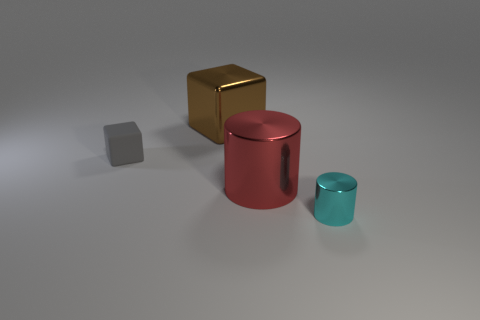Is the number of large metal things that are behind the gray object greater than the number of small brown metallic cylinders?
Offer a very short reply. Yes. Is the number of rubber objects that are on the right side of the rubber block the same as the number of tiny cyan shiny cylinders behind the large block?
Your answer should be very brief. Yes. There is a object that is both behind the large cylinder and right of the gray cube; what is its color?
Your answer should be compact. Brown. Are there more things that are to the right of the large brown block than tiny gray rubber objects that are behind the tiny gray rubber block?
Give a very brief answer. Yes. There is a metal cylinder that is in front of the red shiny object; does it have the same size as the rubber block?
Provide a succinct answer. Yes. How many big shiny things are in front of the object that is on the left side of the shiny object that is behind the tiny gray object?
Offer a very short reply. 1. What is the size of the metal object that is on the left side of the small cyan object and to the right of the brown block?
Offer a very short reply. Large. How many big metal things are left of the red metal object?
Provide a succinct answer. 1. Are there fewer cylinders on the left side of the big red metal cylinder than big cubes to the left of the small cyan shiny cylinder?
Your answer should be very brief. Yes. There is a big object in front of the big thing behind the tiny object on the left side of the cyan cylinder; what is its shape?
Your response must be concise. Cylinder. 